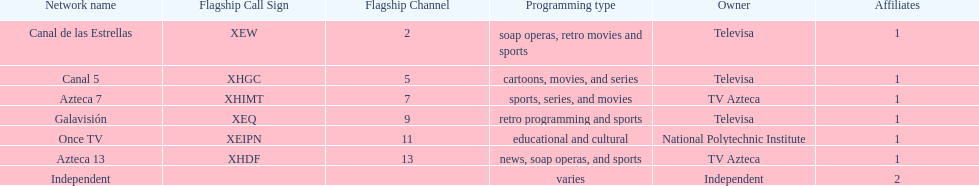Who is the only network owner listed in a consecutive order in the chart? Televisa. 